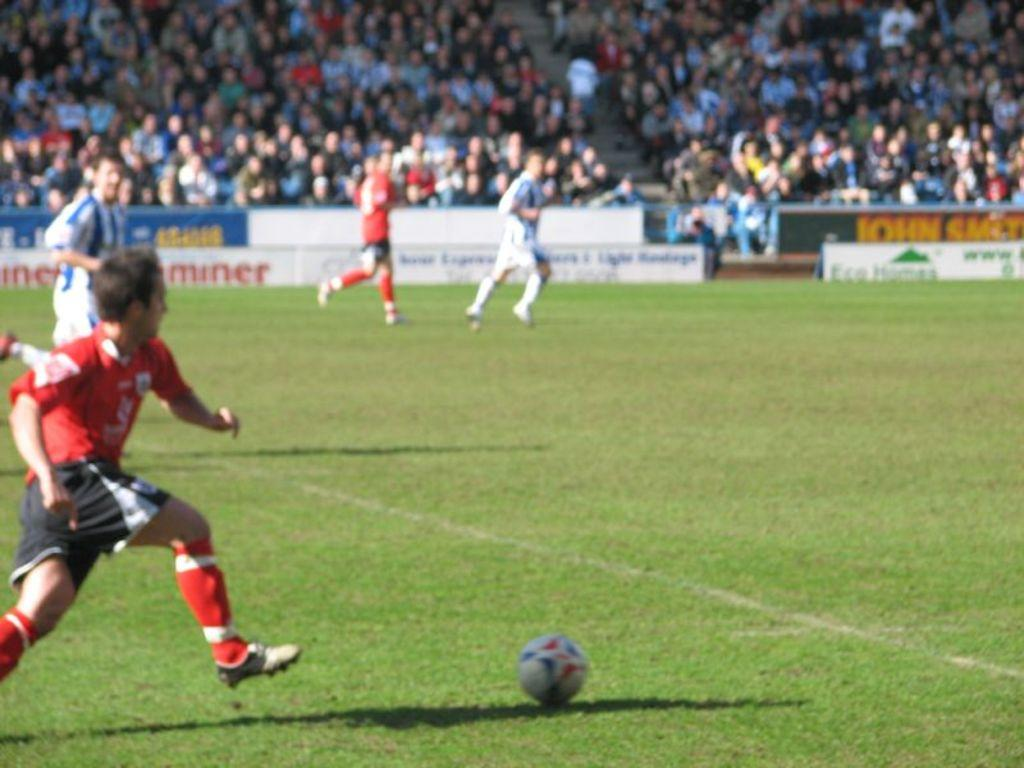<image>
Share a concise interpretation of the image provided. An ad around the edge of a soccer field ends with the letters "miner". 